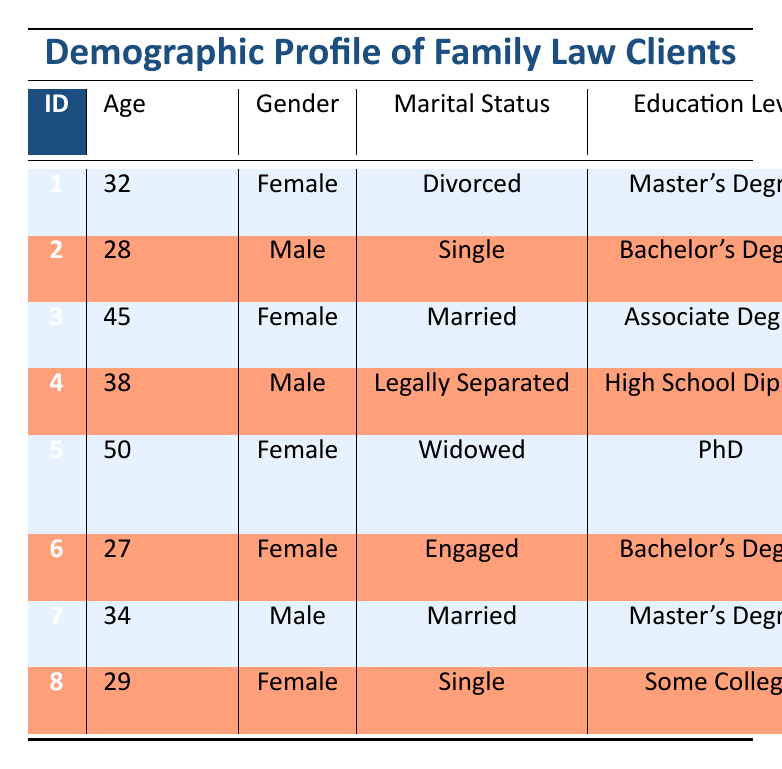What is the age of the client who is engaged? Looking at the table, the engaged client is the one with client_id 6, who is 27 years old.
Answer: 27 How many clients have a Master's Degree as their education level? By inspecting the table, client_id 1 and client_id 7 have a Master's Degree, making it a total of 2 clients.
Answer: 2 Is there any client from Seattle, WA? In the table, client_id 6 is from Seattle, WA, so the answer is yes.
Answer: Yes What is the average annual income of male clients? The male clients are client 2, 4, and 7, with annual incomes of 25000, 60000, and 95000 respectively. The sum is 25000 + 60000 + 95000 = 180000. Since there are 3 male clients, the average is 180000 / 3 = 60000.
Answer: 60000 Which marital status is most common among the clients? The table lists the marital statuses: Divorced, Single, Married, Legally Separated, Widowed, and Engaged. Both "Married" has 3 clients (client_id 3, 4) and "Single" has 3 clients (client_id 2, 8), so there's a tie between them.
Answer: Married and Single 